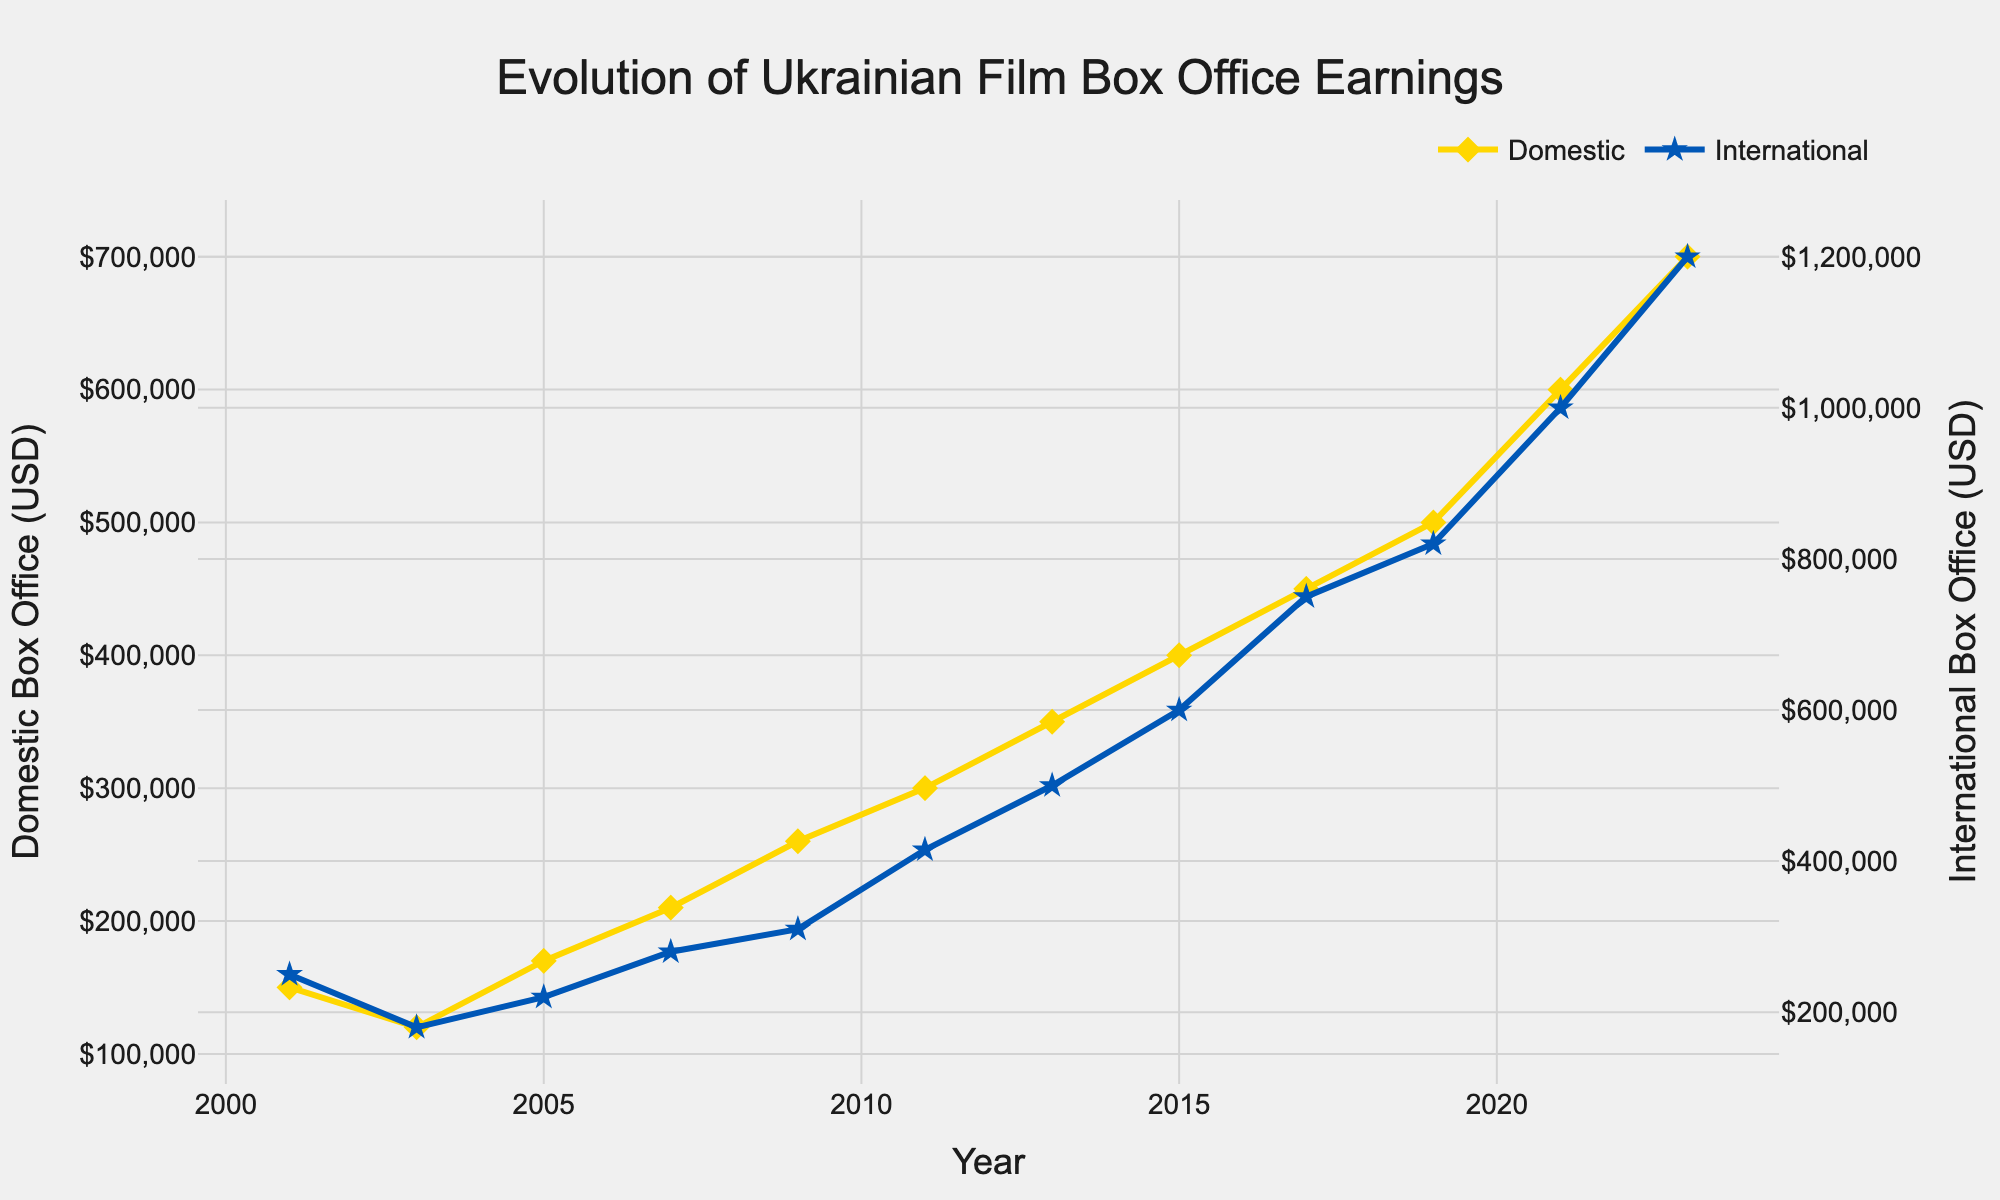What is the title of the plot? The title of the plot is positioned at the top center and reads 'Evolution of Ukrainian Film Box Office Earnings'.
Answer: Evolution of Ukrainian Film Box Office Earnings How many data points are plotted for each category (Domestic and International)? There are two series plotted: Domestic and International. By counting the markers, we see that there are 12 data points for each series.
Answer: 12 Between what years does the data range? The x-axis shows the years, starting from 2001 to 2023.
Answer: 2001 to 2023 Which year had the highest International Box Office earnings and what was the amount? The highest International Box Office earnings can be identified at the peak of the blue line with star markers, which occurs in 2023. The amount is $1,200,000.
Answer: 2023, $1,200,000 In which year did the Domestic Box Office earnings first exceed $400,000? The yellow line with diamond markers first crosses the $400,000 mark in 2015.
Answer: 2015 By how much did the Domestic Box Office earnings increase from 2001 to 2023? The Domestic Box Office earnings in 2001 were $150,000 and in 2023 were $700,000. The increase is calculated as $700,000 - $150,000.
Answer: $550,000 What is the trend in International Box Office earnings from 2001 to 2023? The general trend for International Box Office earnings, represented by the blue line with star markers, shows a steady increase from $250,000 in 2001 to $1,200,000 in 2023.
Answer: Steady increase Which film had higher earnings in 2013: Domestic or International? For the year 2013, refer to the plot points. The Domestic earnings (yellow diamond) are $350,000 and International earnings (blue star) are $500,000, indicating higher International earnings.
Answer: International What is the difference in Box Office earnings between Domestic and International categories in 2017? In 2017, Domestic earnings are $450,000 and International earnings are $750,000. The difference is $750,000 - $450,000.
Answer: $300,000 What is the average International Box Office earnings over the entire period? Sum up all the International earnings: $250,000 + $180,000 + $220,000 + $280,000 + $310,000 + $415,000 + $500,000 + $600,000 + $750,000 + $820,000 + $1,000,000 + $1,200,000 = $6,525,000. Divide by the number of years (12): $6,525,000 / 12.
Answer: $543,750 